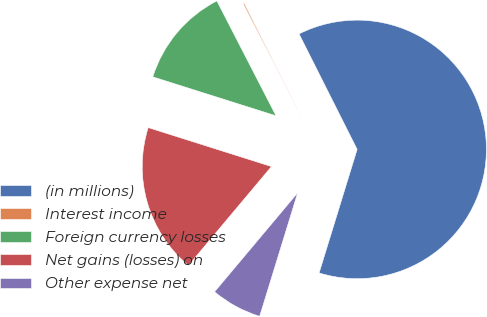Convert chart to OTSL. <chart><loc_0><loc_0><loc_500><loc_500><pie_chart><fcel>(in millions)<fcel>Interest income<fcel>Foreign currency losses<fcel>Net gains (losses) on<fcel>Other expense net<nl><fcel>62.17%<fcel>0.15%<fcel>12.56%<fcel>18.76%<fcel>6.36%<nl></chart> 